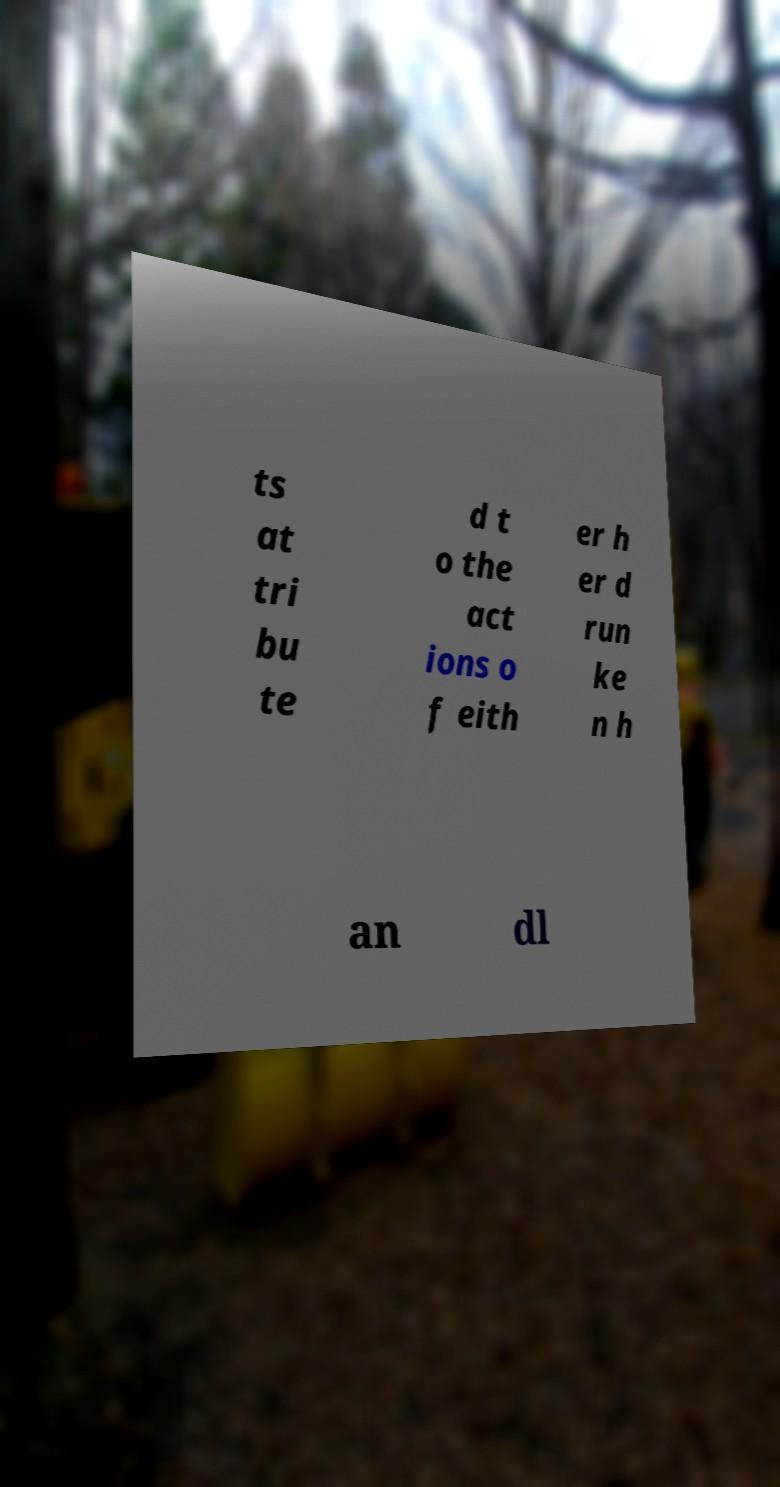Can you read and provide the text displayed in the image?This photo seems to have some interesting text. Can you extract and type it out for me? ts at tri bu te d t o the act ions o f eith er h er d run ke n h an dl 